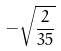<formula> <loc_0><loc_0><loc_500><loc_500>- \sqrt { \frac { 2 } { 3 5 } }</formula> 